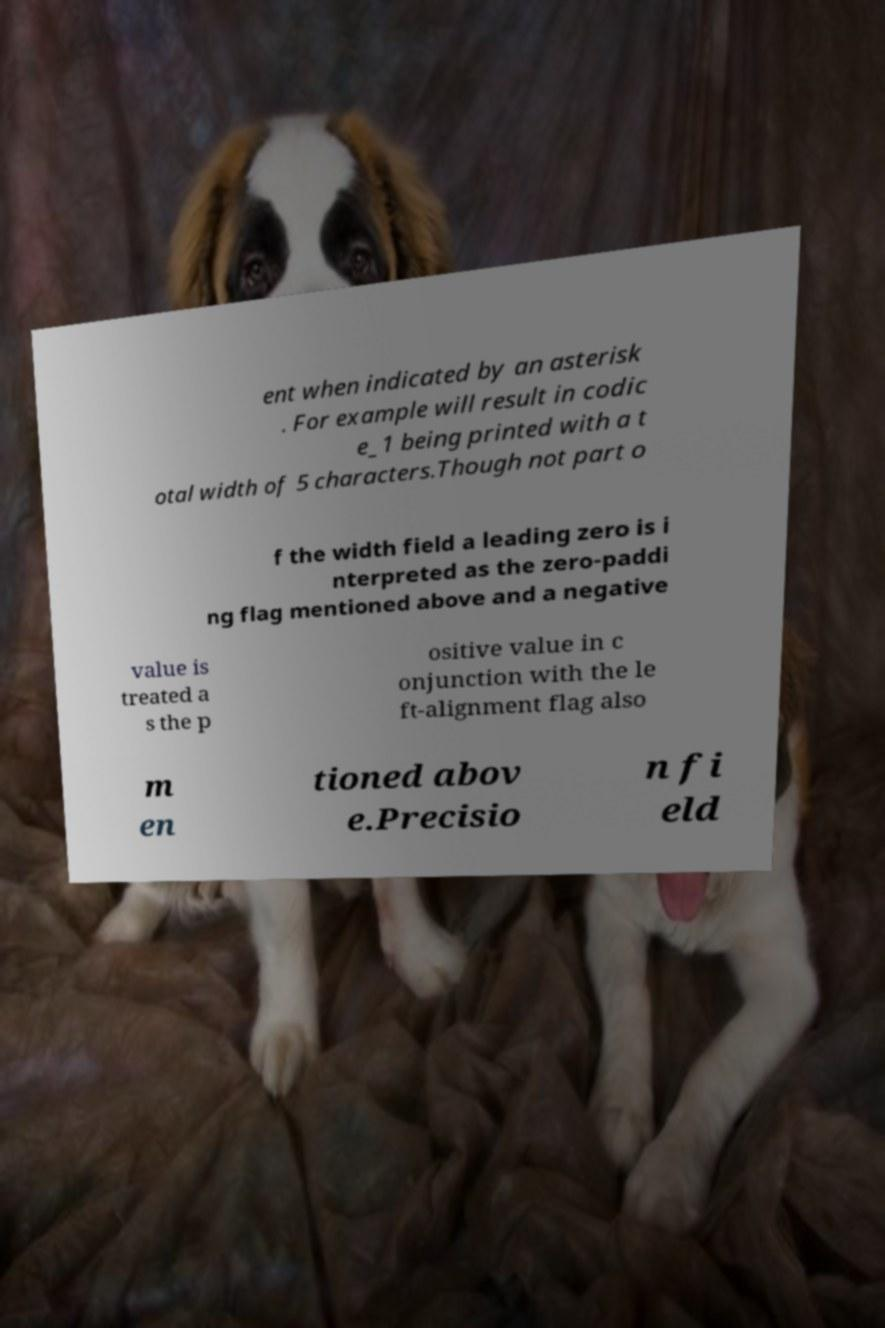Could you assist in decoding the text presented in this image and type it out clearly? ent when indicated by an asterisk . For example will result in codic e_1 being printed with a t otal width of 5 characters.Though not part o f the width field a leading zero is i nterpreted as the zero-paddi ng flag mentioned above and a negative value is treated a s the p ositive value in c onjunction with the le ft-alignment flag also m en tioned abov e.Precisio n fi eld 